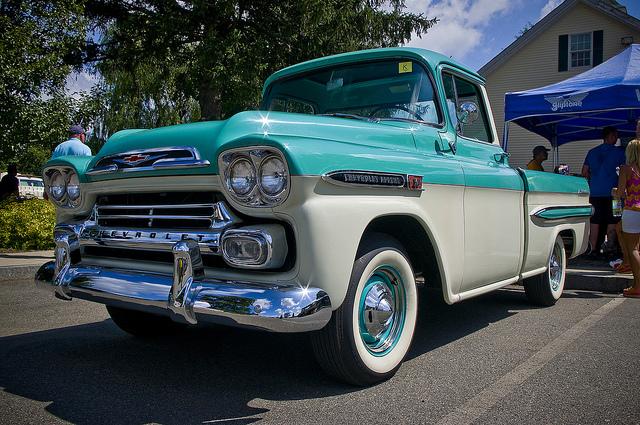What color is this truck?
Answer briefly. Blue and white. What color is the hood of the truck?
Write a very short answer. Teal. Is it raining in this photo?
Quick response, please. No. What kind of car is this?
Short answer required. Truck. Is the bumper chrome?
Short answer required. Yes. Would this truck be a antique?
Quick response, please. Yes. 